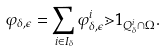<formula> <loc_0><loc_0><loc_500><loc_500>\varphi _ { \delta , \epsilon } = \sum _ { i \in I _ { \delta } } \varphi ^ { i } _ { \delta , \epsilon } \mathbb { m } { 1 } _ { Q ^ { i } _ { \delta } \cap \Omega } .</formula> 